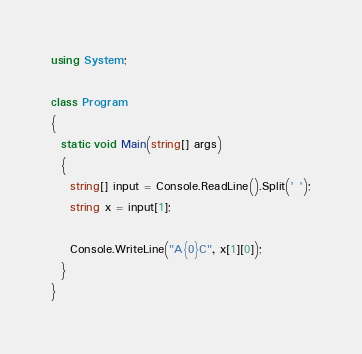Convert code to text. <code><loc_0><loc_0><loc_500><loc_500><_C#_>using System;
 
class Program
{
  static void Main(string[] args)
  {
    string[] input = Console.ReadLine().Split(' ');
    string x = input[1];
    
    Console.WriteLine("A{0}C", x[1][0]);
  }
}</code> 